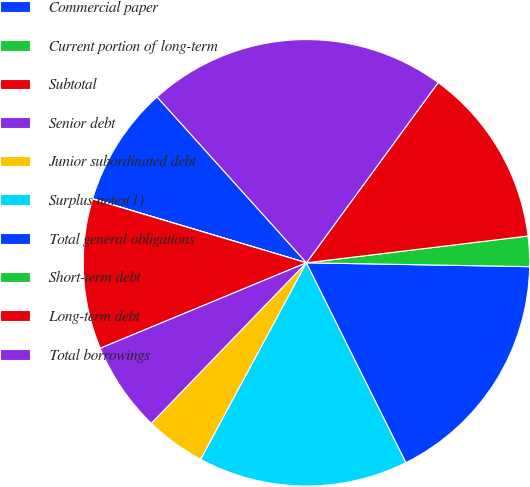<chart> <loc_0><loc_0><loc_500><loc_500><pie_chart><fcel>Commercial paper<fcel>Current portion of long-term<fcel>Subtotal<fcel>Senior debt<fcel>Junior subordinated debt<fcel>Surplus notes(1)<fcel>Total general obligations<fcel>Short-term debt<fcel>Long-term debt<fcel>Total borrowings<nl><fcel>8.7%<fcel>0.02%<fcel>10.87%<fcel>6.53%<fcel>4.36%<fcel>15.21%<fcel>17.37%<fcel>2.19%<fcel>13.04%<fcel>21.71%<nl></chart> 